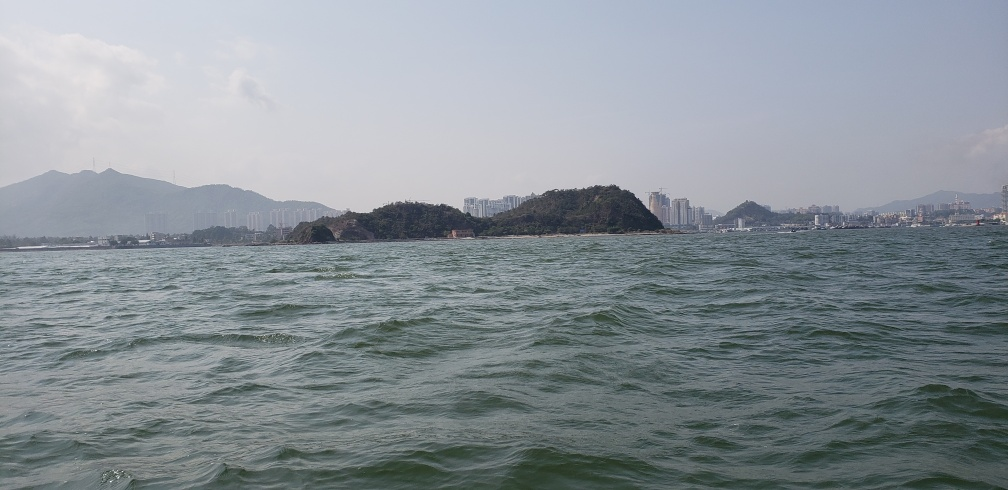Could you infer what the climate might be like in this region? The lush green hills, clear skies, and the overall sunny weather suggest a warm, perhaps subtropical climate. Such regions often experience warm weather year-round with seasonal rain. Is there anything about this image that speaks to the environmental health of the location? The clarity of the water and the visible greenery on land imply a relatively healthy and unpolluted environment. However, without more detailed knowledge or context, it's difficult to make a comprehensive assessment about environmental health purely from this image. 